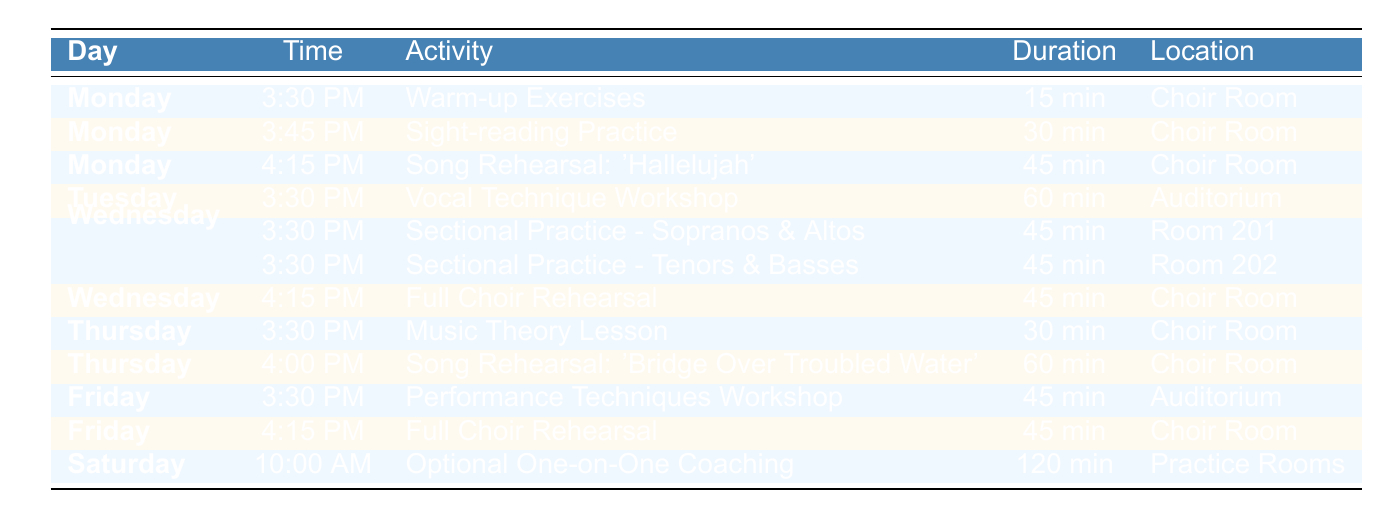What activity is scheduled on Monday at 4:15 PM? The table shows that on Monday at 4:15 PM, the activity is "Song Rehearsal: 'Hallelujah'."
Answer: Song Rehearsal: 'Hallelujah' How long is the vocal technique workshop? The table specifies that the "Vocal Technique Workshop" on Tuesday lasts for 60 minutes.
Answer: 60 min Is there a sectional practice on Wednesday? Yes, the table indicates that on Wednesday there are two sectional practices: one for Sopranos & Altos and another for Tenors & Basses.
Answer: Yes What is the total duration of all activities on Monday? The activities on Monday and their durations are: 15 minutes (Warm-up Exercises) + 30 minutes (Sight-reading Practice) + 45 minutes (Song Rehearsal). Adding these: 15 + 30 + 45 = 90 minutes total.
Answer: 90 min Which day has a performance techniques workshop? According to the table, the "Performance Techniques Workshop" is scheduled for Friday at 3:30 PM.
Answer: Friday What location is used for full choir rehearsals, and how many are scheduled? The location for full choir rehearsals is the "Choir Room." There are two rehearsals scheduled: one on Wednesday at 4:15 PM and another on Friday at 4:15 PM.
Answer: Choir Room, 2 On which day is the optional coaching session scheduled, and what is its duration? The table shows that the "Optional One-on-One Coaching" is scheduled on Saturday at 10:00 AM for a duration of 120 minutes.
Answer: Saturday, 120 min What is the difference in duration between the vocal technique workshop and the music theory lesson? The vocal technique workshop lasts 60 minutes, while the music theory lesson lasts 30 minutes. The difference is 60 - 30 = 30 minutes.
Answer: 30 min Which activity takes place immediately after the warm-up exercises on Monday? The table indicates that the activity right after the "Warm-up Exercises" (15 min) on Monday at 3:30 PM is "Sight-reading Practice" (30 min).
Answer: Sight-reading Practice 